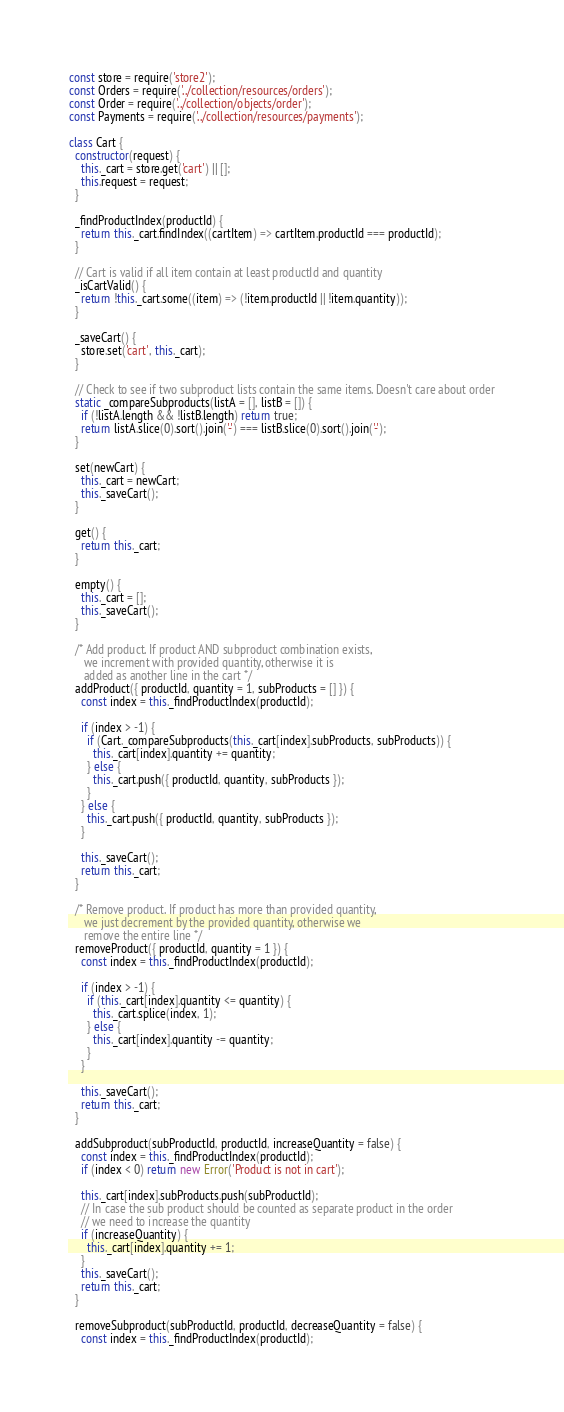Convert code to text. <code><loc_0><loc_0><loc_500><loc_500><_JavaScript_>const store = require('store2');
const Orders = require('../collection/resources/orders');
const Order = require('../collection/objects/order');
const Payments = require('../collection/resources/payments');

class Cart {
  constructor(request) {
    this._cart = store.get('cart') || [];
    this.request = request;
  }

  _findProductIndex(productId) {
    return this._cart.findIndex((cartItem) => cartItem.productId === productId);
  }

  // Cart is valid if all item contain at least productId and quantity
  _isCartValid() {
    return !this._cart.some((item) => (!item.productId || !item.quantity));
  }

  _saveCart() {
    store.set('cart', this._cart);
  }

  // Check to see if two subproduct lists contain the same items. Doesn't care about order
  static _compareSubproducts(listA = [], listB = []) {
    if (!listA.length && !listB.length) return true;
    return listA.slice(0).sort().join('-') === listB.slice(0).sort().join('-');
  }

  set(newCart) {
    this._cart = newCart;
    this._saveCart();
  }

  get() {
    return this._cart;
  }

  empty() {
    this._cart = [];
    this._saveCart();
  }

  /* Add product. If product AND subproduct combination exists,
     we increment with provided quantity, otherwise it is
     added as another line in the cart */
  addProduct({ productId, quantity = 1, subProducts = [] }) {
    const index = this._findProductIndex(productId);

    if (index > -1) {
      if (Cart._compareSubproducts(this._cart[index].subProducts, subProducts)) {
        this._cart[index].quantity += quantity;
      } else {
        this._cart.push({ productId, quantity, subProducts });
      }
    } else {
      this._cart.push({ productId, quantity, subProducts });
    }

    this._saveCart();
    return this._cart;
  }

  /* Remove product. If product has more than provided quantity,
     we just decrement by the provided quantity, otherwise we
     remove the entire line */
  removeProduct({ productId, quantity = 1 }) {
    const index = this._findProductIndex(productId);

    if (index > -1) {
      if (this._cart[index].quantity <= quantity) {
        this._cart.splice(index, 1);
      } else {
        this._cart[index].quantity -= quantity;
      }
    }

    this._saveCart();
    return this._cart;
  }

  addSubproduct(subProductId, productId, increaseQuantity = false) {
    const index = this._findProductIndex(productId);
    if (index < 0) return new Error('Product is not in cart');

    this._cart[index].subProducts.push(subProductId);
    // In case the sub product should be counted as separate product in the order
    // we need to increase the quantity
    if (increaseQuantity) {
      this._cart[index].quantity += 1;
    }
    this._saveCart();
    return this._cart;
  }

  removeSubproduct(subProductId, productId, decreaseQuantity = false) {
    const index = this._findProductIndex(productId);</code> 